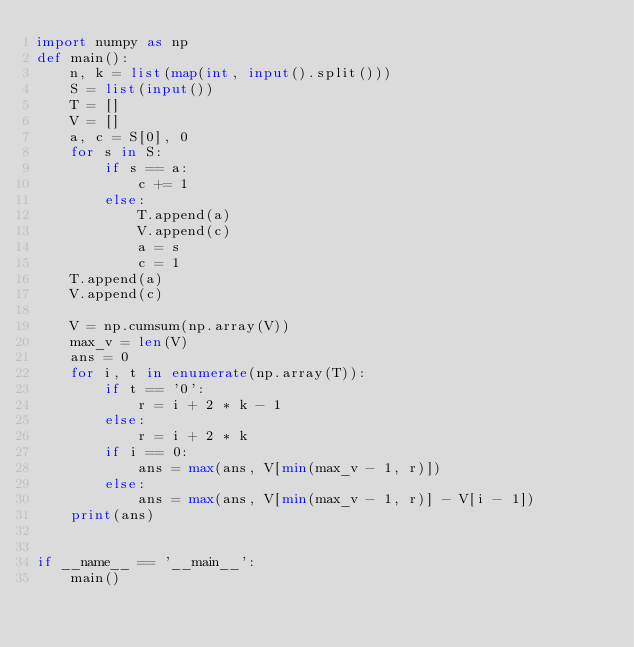Convert code to text. <code><loc_0><loc_0><loc_500><loc_500><_Python_>import numpy as np
def main():
    n, k = list(map(int, input().split()))
    S = list(input())
    T = []
    V = []
    a, c = S[0], 0
    for s in S:
        if s == a:
            c += 1
        else:
            T.append(a)
            V.append(c)
            a = s
            c = 1
    T.append(a)
    V.append(c)

    V = np.cumsum(np.array(V))
    max_v = len(V)
    ans = 0
    for i, t in enumerate(np.array(T)):
        if t == '0':
            r = i + 2 * k - 1
        else:
            r = i + 2 * k
        if i == 0:
            ans = max(ans, V[min(max_v - 1, r)])
        else:
            ans = max(ans, V[min(max_v - 1, r)] - V[i - 1])
    print(ans)


if __name__ == '__main__':
    main()
</code> 